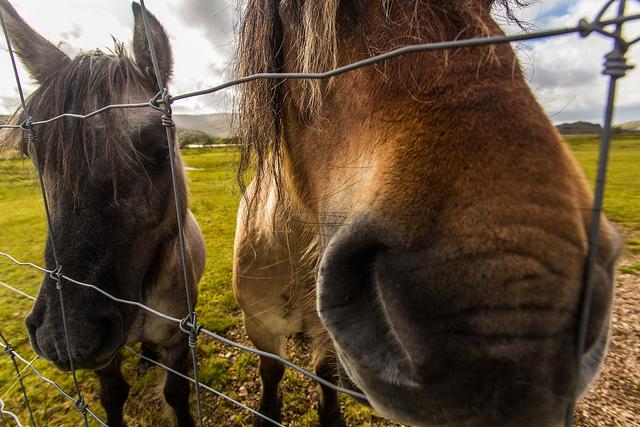Are these two pigs?
Concise answer only. No. Do you see any barb wire?
Give a very brief answer. Yes. Are the animals close to the photographer?
Keep it brief. Yes. 